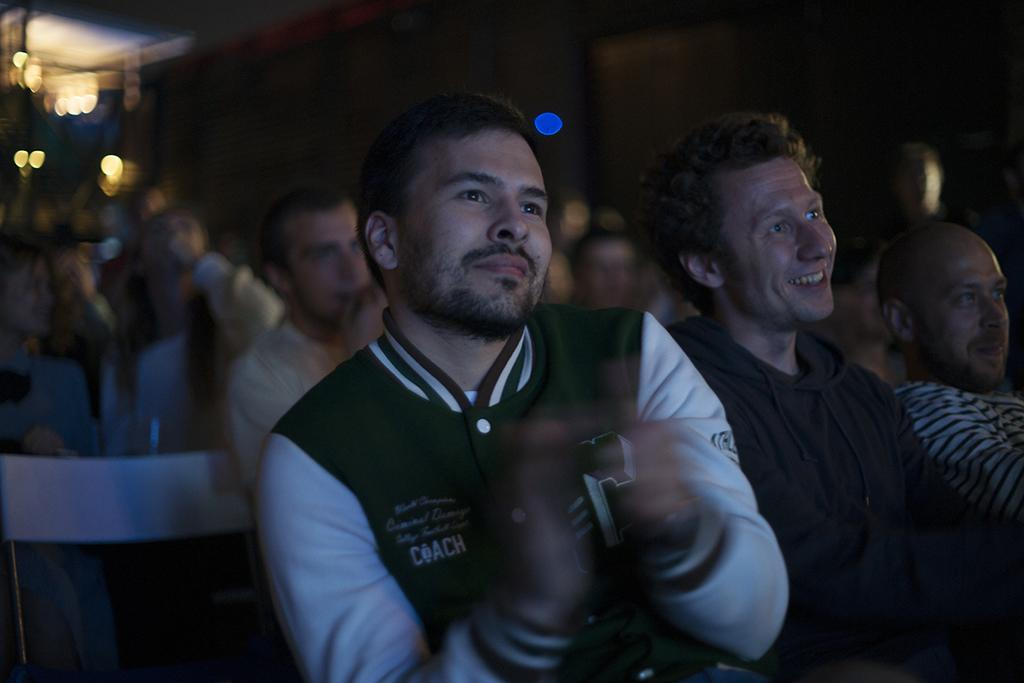How many people are in the image? There are persons in the image, but the exact number is not specified. What can be seen in the background of the image? There are lights and other objects in the background of the image. What type of bubble is being used for the activity in the image? There is no bubble or activity involving a bubble present in the image. What key is used to unlock the door in the image? There is no door or key present in the image. 